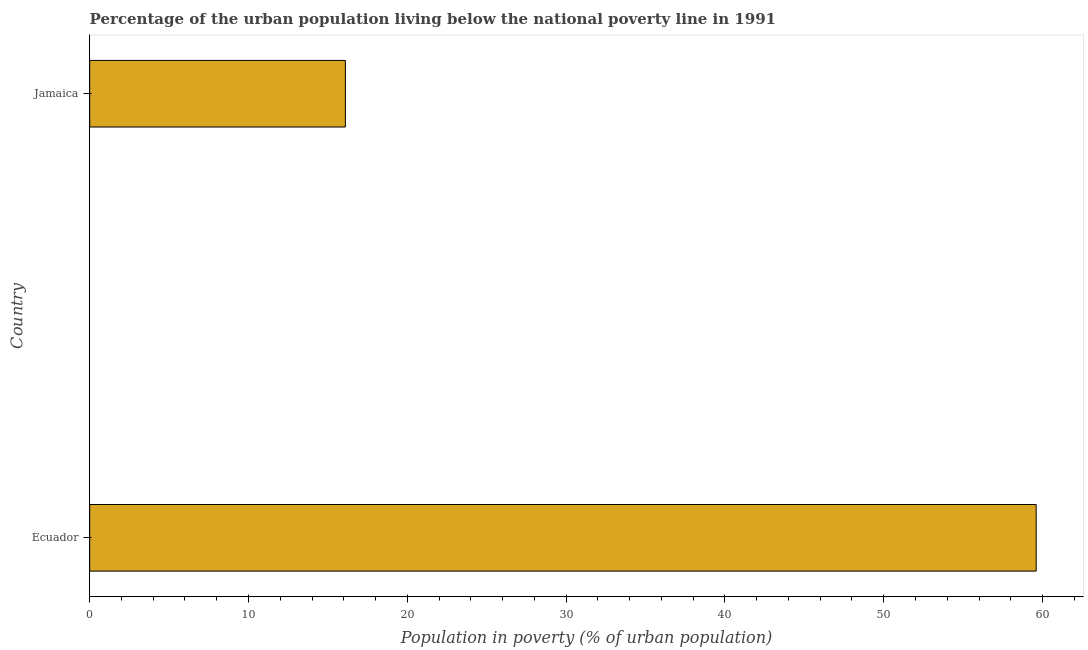What is the title of the graph?
Give a very brief answer. Percentage of the urban population living below the national poverty line in 1991. What is the label or title of the X-axis?
Give a very brief answer. Population in poverty (% of urban population). What is the percentage of urban population living below poverty line in Ecuador?
Keep it short and to the point. 59.6. Across all countries, what is the maximum percentage of urban population living below poverty line?
Provide a succinct answer. 59.6. In which country was the percentage of urban population living below poverty line maximum?
Offer a terse response. Ecuador. In which country was the percentage of urban population living below poverty line minimum?
Your answer should be compact. Jamaica. What is the sum of the percentage of urban population living below poverty line?
Provide a short and direct response. 75.7. What is the difference between the percentage of urban population living below poverty line in Ecuador and Jamaica?
Ensure brevity in your answer.  43.5. What is the average percentage of urban population living below poverty line per country?
Offer a terse response. 37.85. What is the median percentage of urban population living below poverty line?
Make the answer very short. 37.85. What is the ratio of the percentage of urban population living below poverty line in Ecuador to that in Jamaica?
Provide a short and direct response. 3.7. In how many countries, is the percentage of urban population living below poverty line greater than the average percentage of urban population living below poverty line taken over all countries?
Make the answer very short. 1. Are all the bars in the graph horizontal?
Offer a terse response. Yes. How many countries are there in the graph?
Give a very brief answer. 2. What is the Population in poverty (% of urban population) in Ecuador?
Your response must be concise. 59.6. What is the Population in poverty (% of urban population) of Jamaica?
Offer a very short reply. 16.1. What is the difference between the Population in poverty (% of urban population) in Ecuador and Jamaica?
Your response must be concise. 43.5. What is the ratio of the Population in poverty (% of urban population) in Ecuador to that in Jamaica?
Make the answer very short. 3.7. 